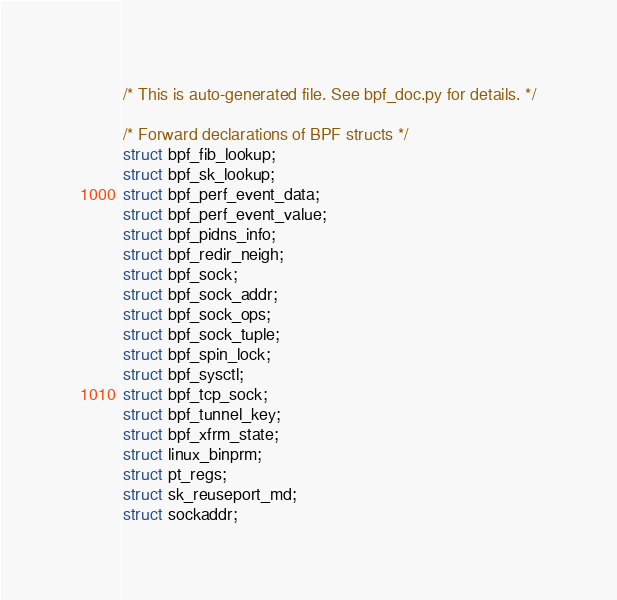<code> <loc_0><loc_0><loc_500><loc_500><_C_>/* This is auto-generated file. See bpf_doc.py for details. */

/* Forward declarations of BPF structs */
struct bpf_fib_lookup;
struct bpf_sk_lookup;
struct bpf_perf_event_data;
struct bpf_perf_event_value;
struct bpf_pidns_info;
struct bpf_redir_neigh;
struct bpf_sock;
struct bpf_sock_addr;
struct bpf_sock_ops;
struct bpf_sock_tuple;
struct bpf_spin_lock;
struct bpf_sysctl;
struct bpf_tcp_sock;
struct bpf_tunnel_key;
struct bpf_xfrm_state;
struct linux_binprm;
struct pt_regs;
struct sk_reuseport_md;
struct sockaddr;</code> 